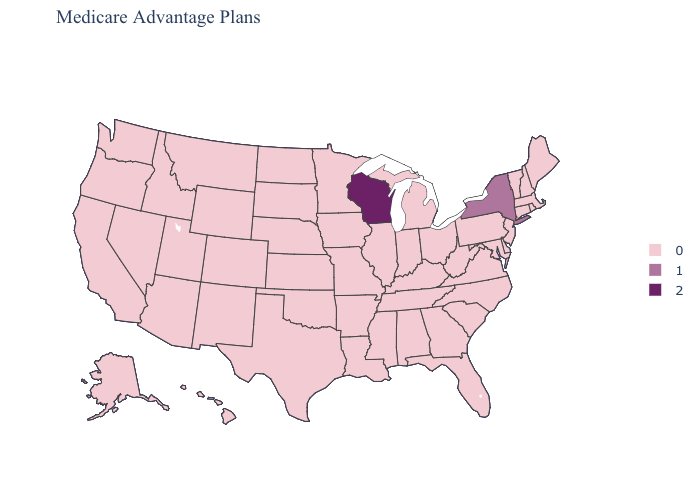What is the highest value in the South ?
Keep it brief. 0. How many symbols are there in the legend?
Be succinct. 3. What is the value of Minnesota?
Keep it brief. 0. What is the lowest value in the USA?
Short answer required. 0. What is the value of New Hampshire?
Write a very short answer. 0. Name the states that have a value in the range 2?
Short answer required. Wisconsin. Does Indiana have the highest value in the MidWest?
Be succinct. No. What is the lowest value in the South?
Short answer required. 0. Does the map have missing data?
Answer briefly. No. What is the value of South Carolina?
Be succinct. 0. Name the states that have a value in the range 2?
Quick response, please. Wisconsin. Which states have the lowest value in the USA?
Write a very short answer. Alaska, Alabama, Arkansas, Arizona, California, Colorado, Connecticut, Delaware, Florida, Georgia, Hawaii, Iowa, Idaho, Illinois, Indiana, Kansas, Kentucky, Louisiana, Massachusetts, Maryland, Maine, Michigan, Minnesota, Missouri, Mississippi, Montana, North Carolina, North Dakota, Nebraska, New Hampshire, New Jersey, New Mexico, Nevada, Ohio, Oklahoma, Oregon, Pennsylvania, Rhode Island, South Carolina, South Dakota, Tennessee, Texas, Utah, Virginia, Vermont, Washington, West Virginia, Wyoming. What is the value of Missouri?
Keep it brief. 0. 